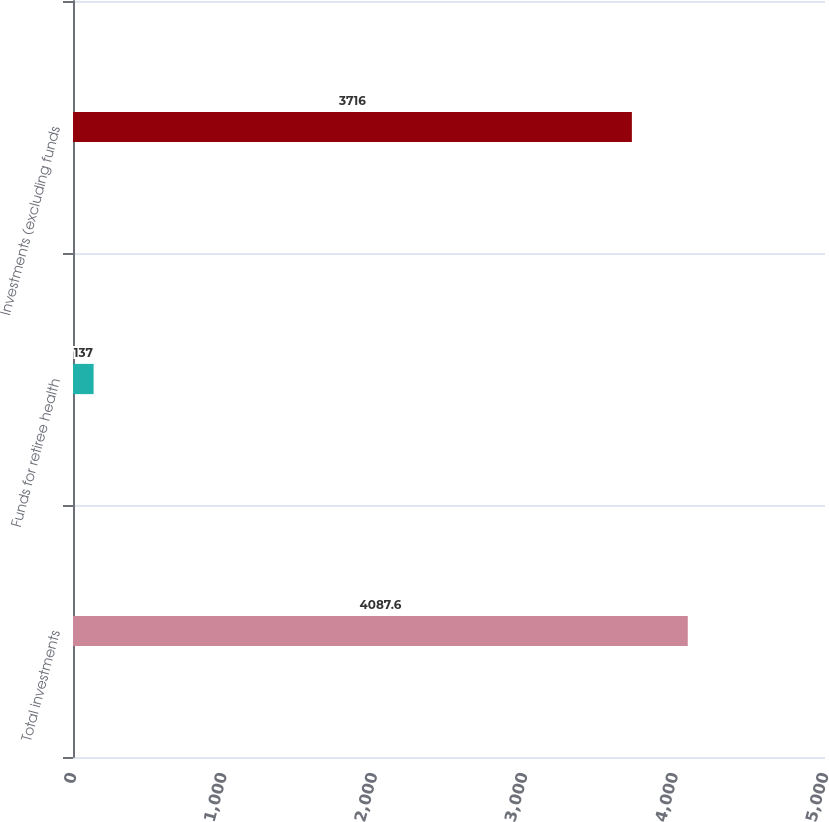<chart> <loc_0><loc_0><loc_500><loc_500><bar_chart><fcel>Total investments<fcel>Funds for retiree health<fcel>Investments (excluding funds<nl><fcel>4087.6<fcel>137<fcel>3716<nl></chart> 